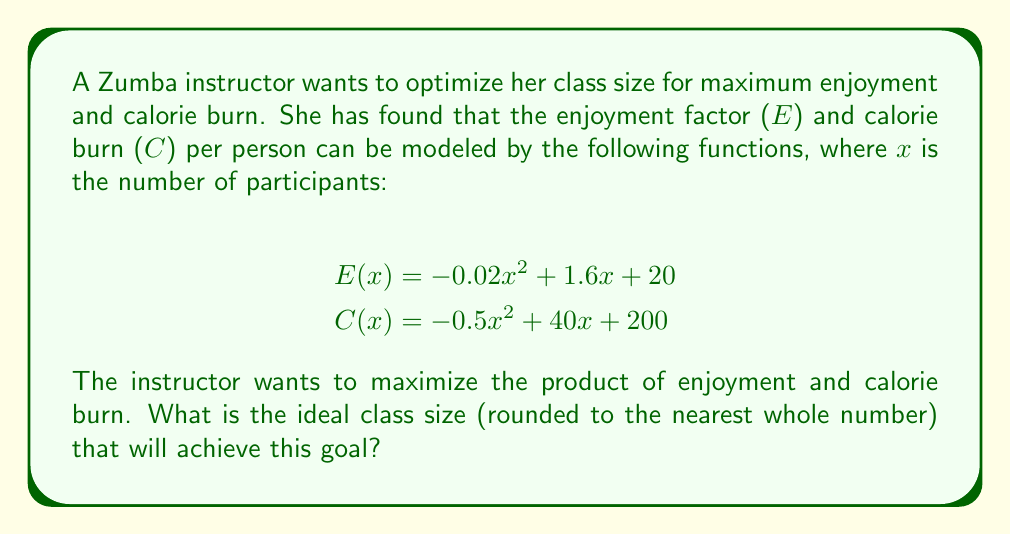Solve this math problem. To solve this optimization problem, we need to follow these steps:

1) First, let's define our objective function. We want to maximize the product of enjoyment and calorie burn:

   $f(x) = E(x) \cdot C(x)$

2) Expand this function:

   $f(x) = (-0.02x^2 + 1.6x + 20) \cdot (-0.5x^2 + 40x + 200)$

3) Multiply these terms:

   $f(x) = 0.01x^4 - 0.8x^3 - 10x^2 + (-0.02x^2 + 1.6x + 20)(40x + 200)$
   $f(x) = 0.01x^4 - 0.8x^3 - 10x^2 + (-0.8x^3 + 64x^2 + 800x - 4x^2 + 320x + 4000)$
   $f(x) = 0.01x^4 - 1.6x^3 + 50x^2 + 1120x + 4000$

4) To find the maximum, we need to find where the derivative of this function equals zero:

   $f'(x) = 0.04x^3 - 4.8x^2 + 100x + 1120$

5) Set this equal to zero and solve:

   $0.04x^3 - 4.8x^2 + 100x + 1120 = 0$

   This is a cubic equation and can be solved using numerical methods or a graphing calculator. The solution that falls within a reasonable class size is approximately 39.6.

6) To confirm this is a maximum, we can check the second derivative:

   $f''(x) = 0.12x^2 - 9.6x + 100$

   At $x = 39.6$, $f''(39.6) < 0$, confirming this is indeed a maximum.

7) Since we need to round to the nearest whole number, our final answer is 40.
Answer: The ideal class size for maximum enjoyment and calorie burn is 40 participants. 